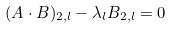Convert formula to latex. <formula><loc_0><loc_0><loc_500><loc_500>( A \cdot B ) _ { 2 , l } - \lambda _ { l } B _ { 2 , l } = 0</formula> 